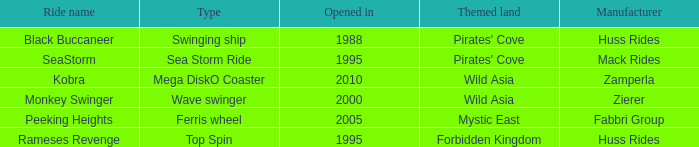What ride was manufactured by Zierer? Monkey Swinger. 